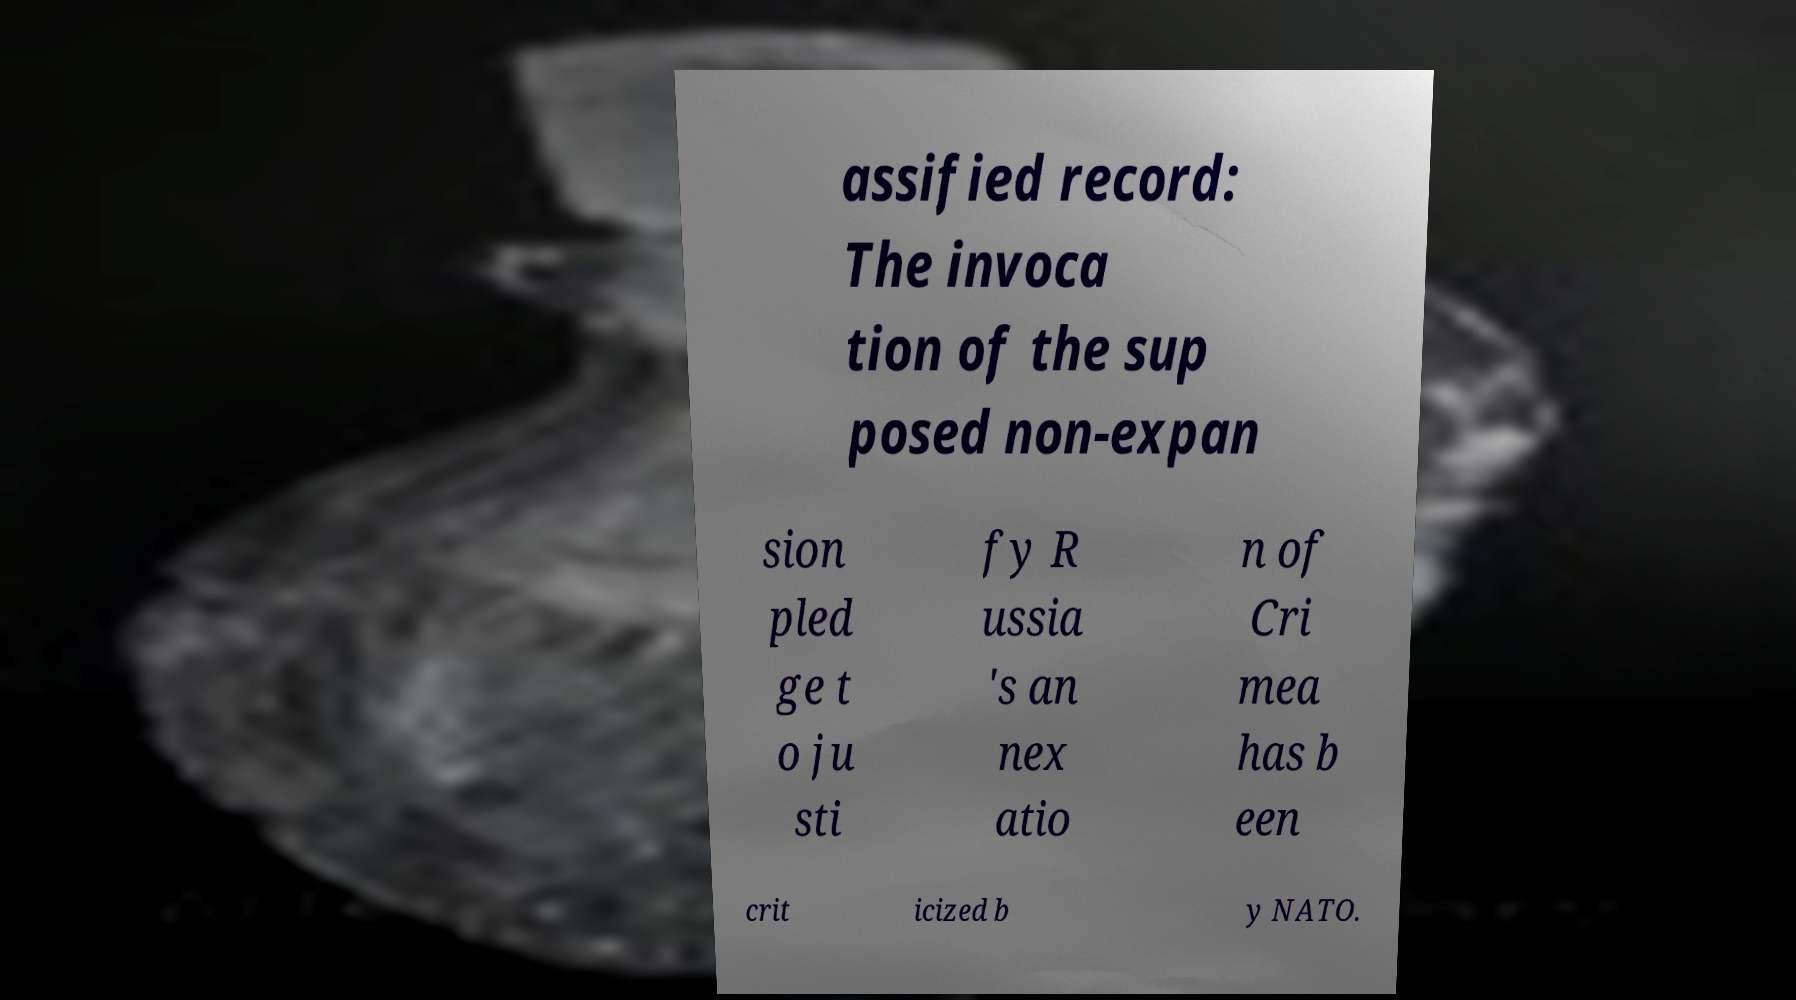Please read and relay the text visible in this image. What does it say? assified record: The invoca tion of the sup posed non-expan sion pled ge t o ju sti fy R ussia 's an nex atio n of Cri mea has b een crit icized b y NATO. 